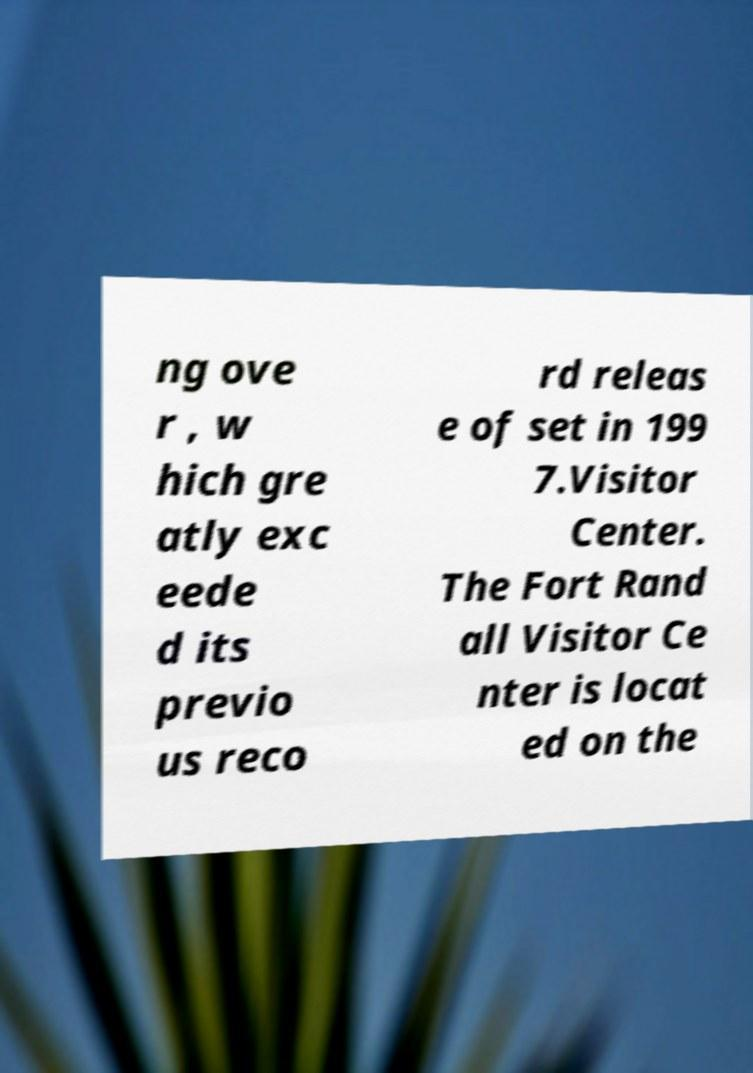Could you extract and type out the text from this image? ng ove r , w hich gre atly exc eede d its previo us reco rd releas e of set in 199 7.Visitor Center. The Fort Rand all Visitor Ce nter is locat ed on the 